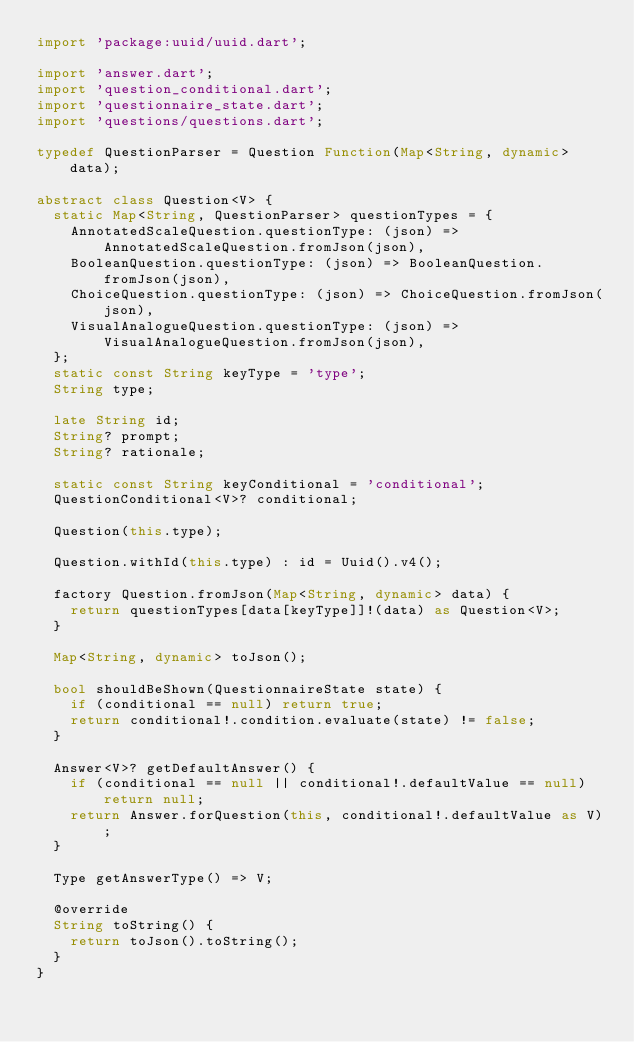<code> <loc_0><loc_0><loc_500><loc_500><_Dart_>import 'package:uuid/uuid.dart';

import 'answer.dart';
import 'question_conditional.dart';
import 'questionnaire_state.dart';
import 'questions/questions.dart';

typedef QuestionParser = Question Function(Map<String, dynamic> data);

abstract class Question<V> {
  static Map<String, QuestionParser> questionTypes = {
    AnnotatedScaleQuestion.questionType: (json) => AnnotatedScaleQuestion.fromJson(json),
    BooleanQuestion.questionType: (json) => BooleanQuestion.fromJson(json),
    ChoiceQuestion.questionType: (json) => ChoiceQuestion.fromJson(json),
    VisualAnalogueQuestion.questionType: (json) => VisualAnalogueQuestion.fromJson(json),
  };
  static const String keyType = 'type';
  String type;

  late String id;
  String? prompt;
  String? rationale;

  static const String keyConditional = 'conditional';
  QuestionConditional<V>? conditional;

  Question(this.type);

  Question.withId(this.type) : id = Uuid().v4();

  factory Question.fromJson(Map<String, dynamic> data) {
    return questionTypes[data[keyType]]!(data) as Question<V>;
  }

  Map<String, dynamic> toJson();

  bool shouldBeShown(QuestionnaireState state) {
    if (conditional == null) return true;
    return conditional!.condition.evaluate(state) != false;
  }

  Answer<V>? getDefaultAnswer() {
    if (conditional == null || conditional!.defaultValue == null) return null;
    return Answer.forQuestion(this, conditional!.defaultValue as V);
  }

  Type getAnswerType() => V;

  @override
  String toString() {
    return toJson().toString();
  }
}
</code> 